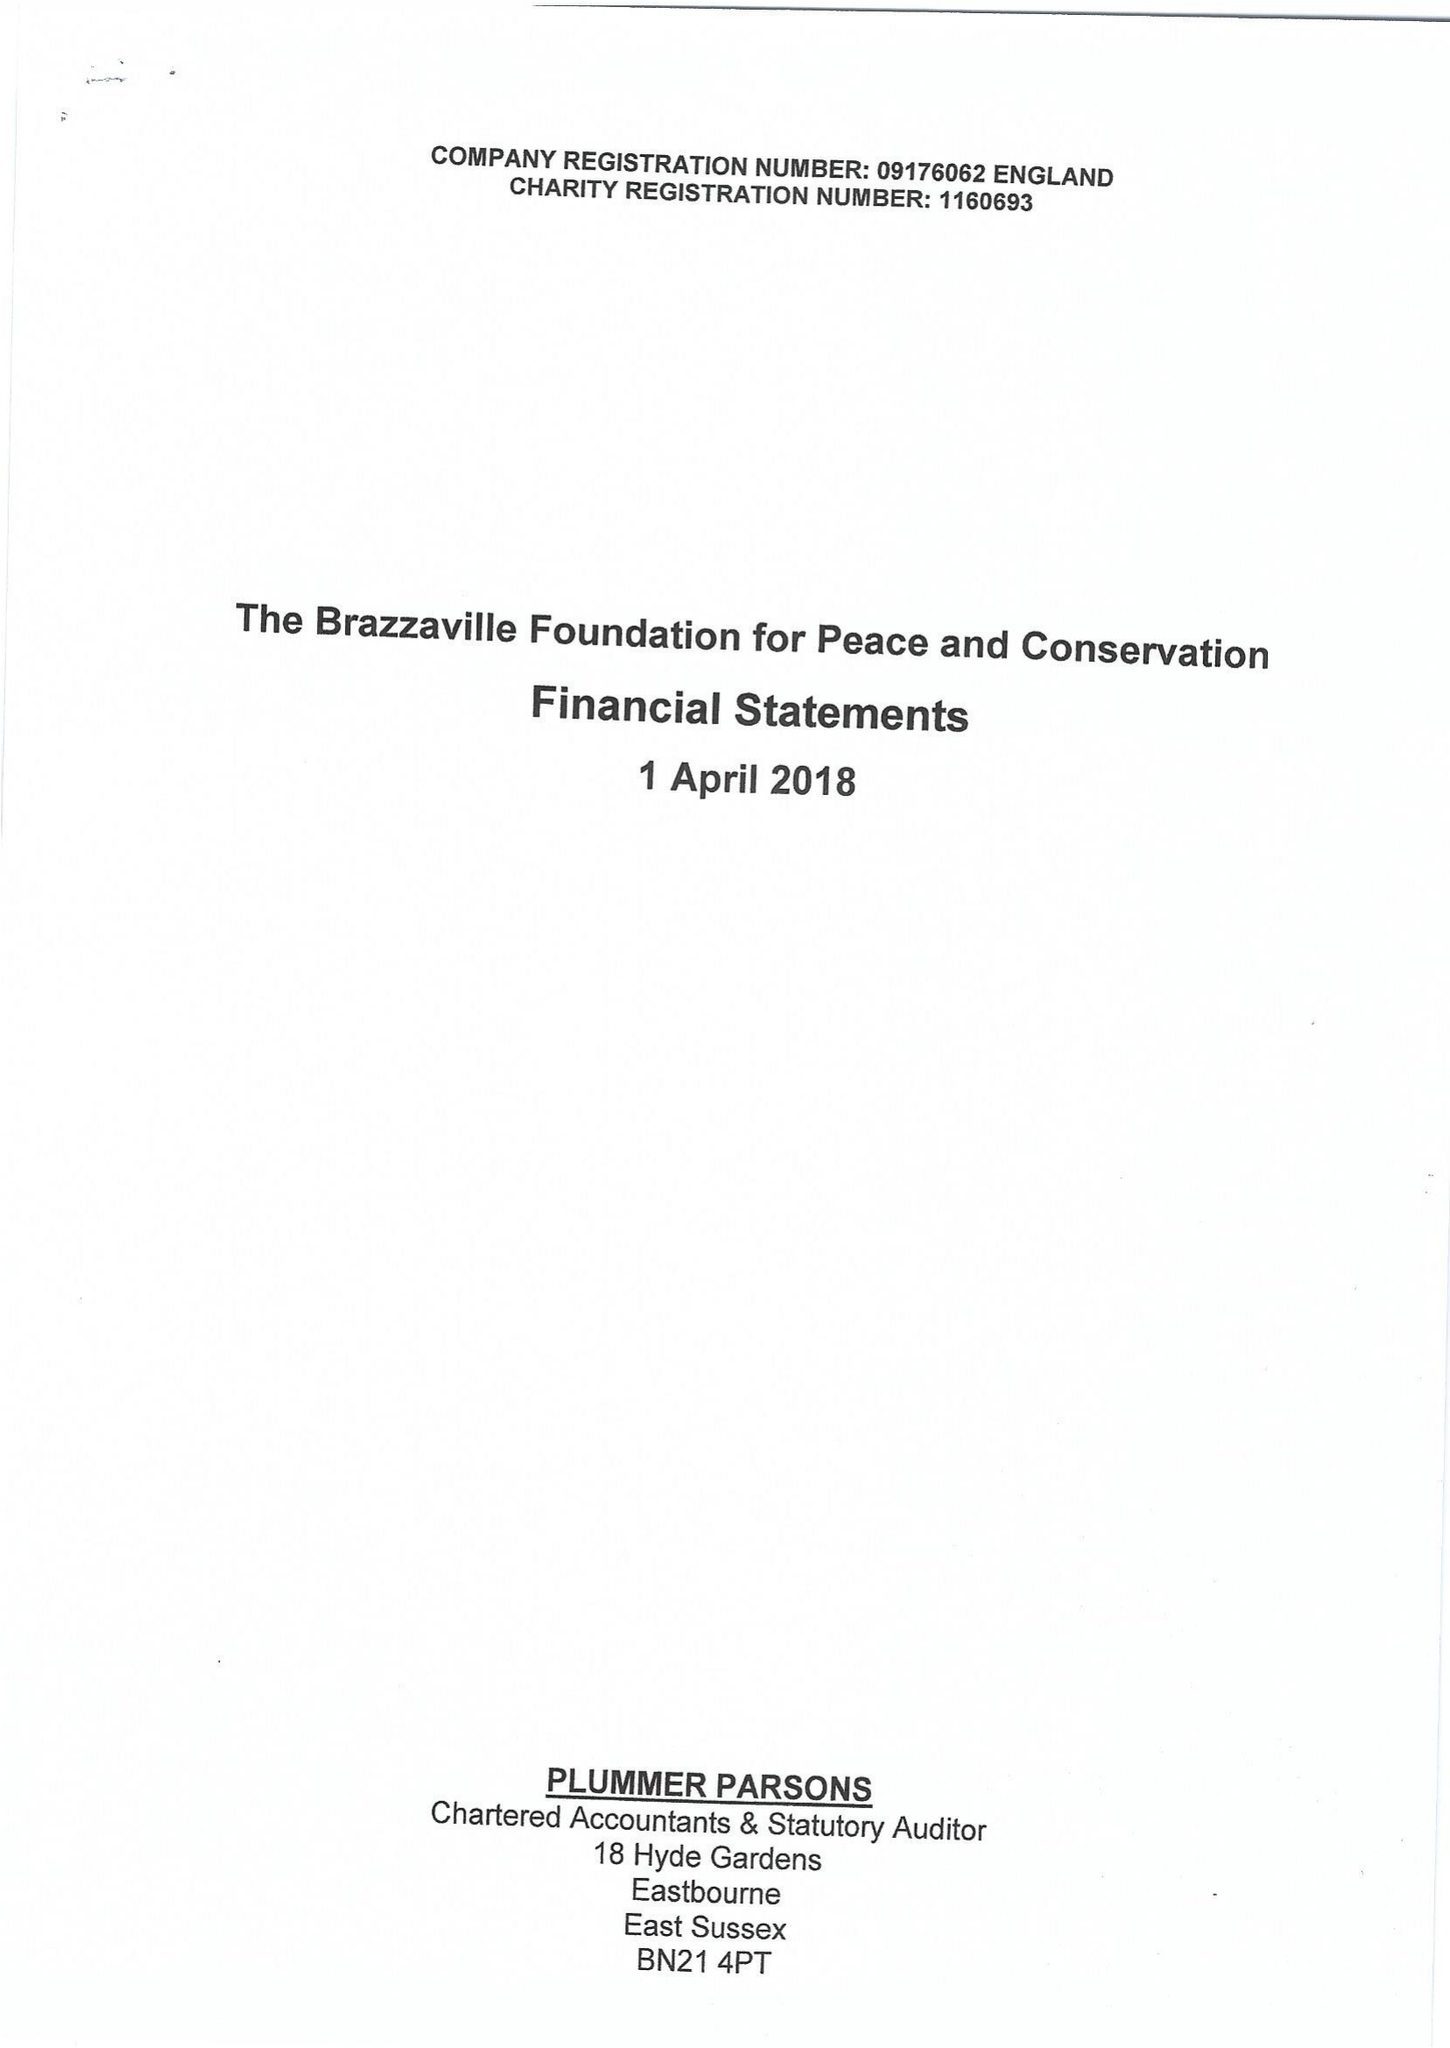What is the value for the charity_name?
Answer the question using a single word or phrase. The Brazzaville Foundation 